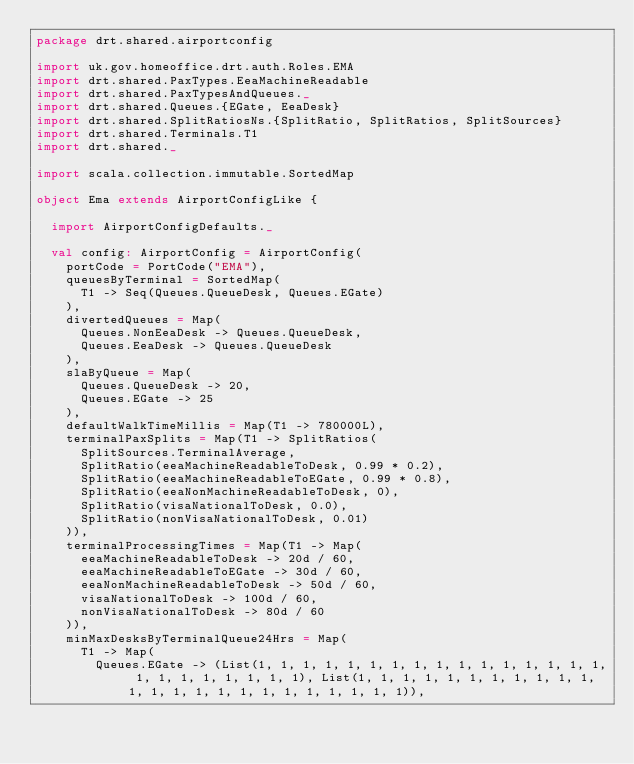Convert code to text. <code><loc_0><loc_0><loc_500><loc_500><_Scala_>package drt.shared.airportconfig

import uk.gov.homeoffice.drt.auth.Roles.EMA
import drt.shared.PaxTypes.EeaMachineReadable
import drt.shared.PaxTypesAndQueues._
import drt.shared.Queues.{EGate, EeaDesk}
import drt.shared.SplitRatiosNs.{SplitRatio, SplitRatios, SplitSources}
import drt.shared.Terminals.T1
import drt.shared._

import scala.collection.immutable.SortedMap

object Ema extends AirportConfigLike {

  import AirportConfigDefaults._

  val config: AirportConfig = AirportConfig(
    portCode = PortCode("EMA"),
    queuesByTerminal = SortedMap(
      T1 -> Seq(Queues.QueueDesk, Queues.EGate)
    ),
    divertedQueues = Map(
      Queues.NonEeaDesk -> Queues.QueueDesk,
      Queues.EeaDesk -> Queues.QueueDesk
    ),
    slaByQueue = Map(
      Queues.QueueDesk -> 20,
      Queues.EGate -> 25
    ),
    defaultWalkTimeMillis = Map(T1 -> 780000L),
    terminalPaxSplits = Map(T1 -> SplitRatios(
      SplitSources.TerminalAverage,
      SplitRatio(eeaMachineReadableToDesk, 0.99 * 0.2),
      SplitRatio(eeaMachineReadableToEGate, 0.99 * 0.8),
      SplitRatio(eeaNonMachineReadableToDesk, 0),
      SplitRatio(visaNationalToDesk, 0.0),
      SplitRatio(nonVisaNationalToDesk, 0.01)
    )),
    terminalProcessingTimes = Map(T1 -> Map(
      eeaMachineReadableToDesk -> 20d / 60,
      eeaMachineReadableToEGate -> 30d / 60,
      eeaNonMachineReadableToDesk -> 50d / 60,
      visaNationalToDesk -> 100d / 60,
      nonVisaNationalToDesk -> 80d / 60
    )),
    minMaxDesksByTerminalQueue24Hrs = Map(
      T1 -> Map(
        Queues.EGate -> (List(1, 1, 1, 1, 1, 1, 1, 1, 1, 1, 1, 1, 1, 1, 1, 1, 1, 1, 1, 1, 1, 1, 1, 1), List(1, 1, 1, 1, 1, 1, 1, 1, 1, 1, 1, 1, 1, 1, 1, 1, 1, 1, 1, 1, 1, 1, 1, 1)),</code> 